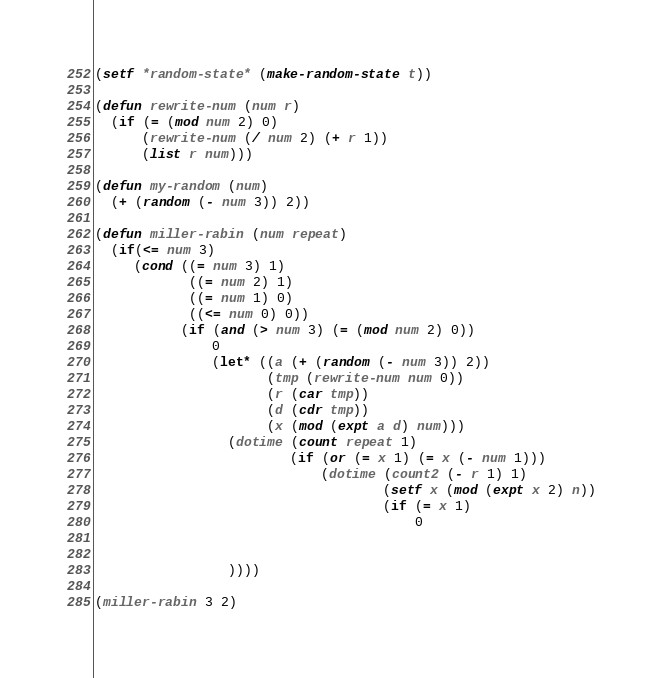<code> <loc_0><loc_0><loc_500><loc_500><_Lisp_>(setf *random-state* (make-random-state t))

(defun rewrite-num (num r)
  (if (= (mod num 2) 0)
      (rewrite-num (/ num 2) (+ r 1))
      (list r num)))
      
(defun my-random (num)
  (+ (random (- num 3)) 2))
  
(defun miller-rabin (num repeat)
  (if(<= num 3)
     (cond ((= num 3) 1)
            ((= num 2) 1)
            ((= num 1) 0)
            ((<= num 0) 0))
           (if (and (> num 3) (= (mod num 2) 0))
               0
               (let* ((a (+ (random (- num 3)) 2))
                      (tmp (rewrite-num num 0))
                      (r (car tmp))
                      (d (cdr tmp))
                      (x (mod (expt a d) num)))
                 (dotime (count repeat 1)
                         (if (or (= x 1) (= x (- num 1)))
                             (dotime (count2 (- r 1) 1)
                                     (setf x (mod (expt x 2) n))
                                     (if (= x 1)
                                         0
                                         
                 
                 ))))

(miller-rabin 3 2)
</code> 